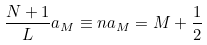Convert formula to latex. <formula><loc_0><loc_0><loc_500><loc_500>\frac { N + 1 } { L } a _ { M } \equiv n a _ { M } = M + \frac { 1 } { 2 }</formula> 